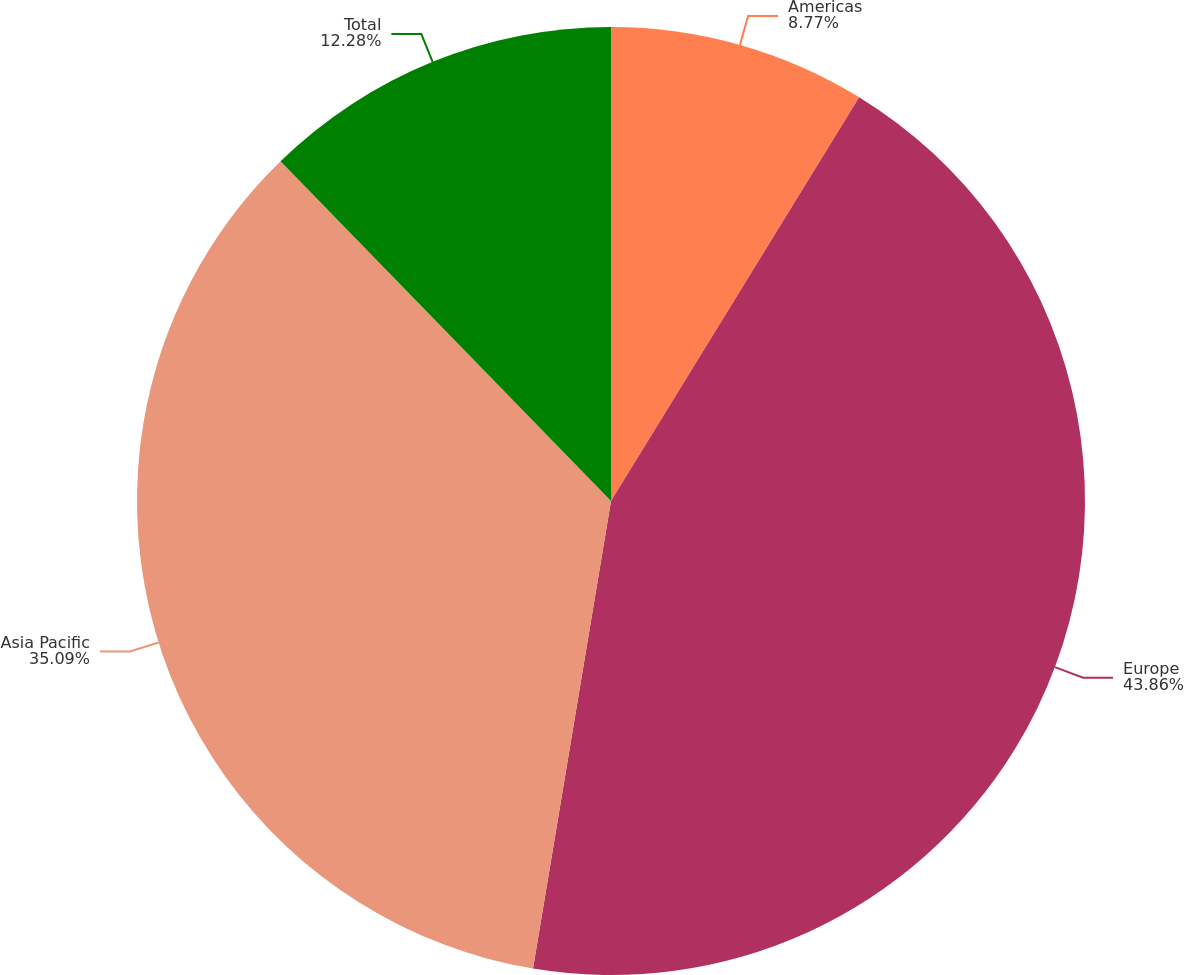<chart> <loc_0><loc_0><loc_500><loc_500><pie_chart><fcel>Americas<fcel>Europe<fcel>Asia Pacific<fcel>Total<nl><fcel>8.77%<fcel>43.86%<fcel>35.09%<fcel>12.28%<nl></chart> 